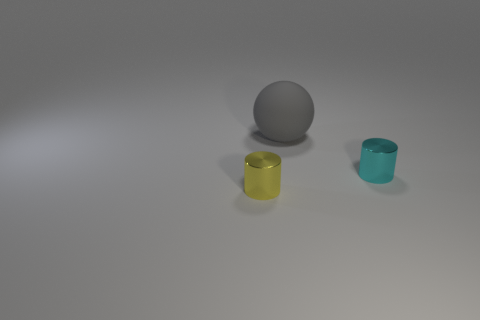Add 3 large gray spheres. How many objects exist? 6 Subtract all yellow cylinders. How many cylinders are left? 1 Subtract all spheres. How many objects are left? 2 Subtract 0 cyan spheres. How many objects are left? 3 Subtract all cyan spheres. Subtract all cyan cylinders. How many spheres are left? 1 Subtract all green cubes. How many yellow cylinders are left? 1 Subtract all small brown matte cubes. Subtract all cyan cylinders. How many objects are left? 2 Add 2 cyan shiny cylinders. How many cyan shiny cylinders are left? 3 Add 3 large gray things. How many large gray things exist? 4 